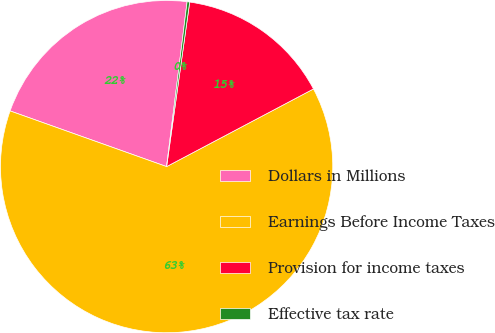Convert chart to OTSL. <chart><loc_0><loc_0><loc_500><loc_500><pie_chart><fcel>Dollars in Millions<fcel>Earnings Before Income Taxes<fcel>Provision for income taxes<fcel>Effective tax rate<nl><fcel>21.53%<fcel>63.18%<fcel>15.04%<fcel>0.25%<nl></chart> 